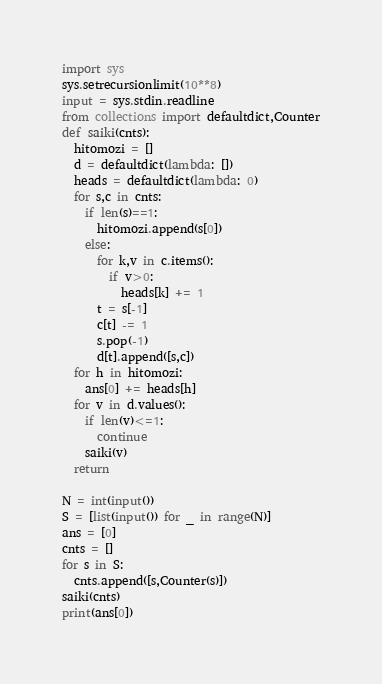Convert code to text. <code><loc_0><loc_0><loc_500><loc_500><_Cython_>import sys
sys.setrecursionlimit(10**8)
input = sys.stdin.readline
from collections import defaultdict,Counter
def saiki(cnts):
  hitomozi = []
  d = defaultdict(lambda: [])
  heads = defaultdict(lambda: 0)
  for s,c in cnts:
    if len(s)==1:
      hitomozi.append(s[0])
    else:
      for k,v in c.items():
        if v>0:
          heads[k] += 1
      t = s[-1]
      c[t] -= 1
      s.pop(-1)
      d[t].append([s,c])
  for h in hitomozi:
    ans[0] += heads[h]
  for v in d.values():
    if len(v)<=1:
      continue
    saiki(v)
  return 

N = int(input())
S = [list(input()) for _ in range(N)]
ans = [0]
cnts = []
for s in S:
  cnts.append([s,Counter(s)])
saiki(cnts)
print(ans[0])
</code> 